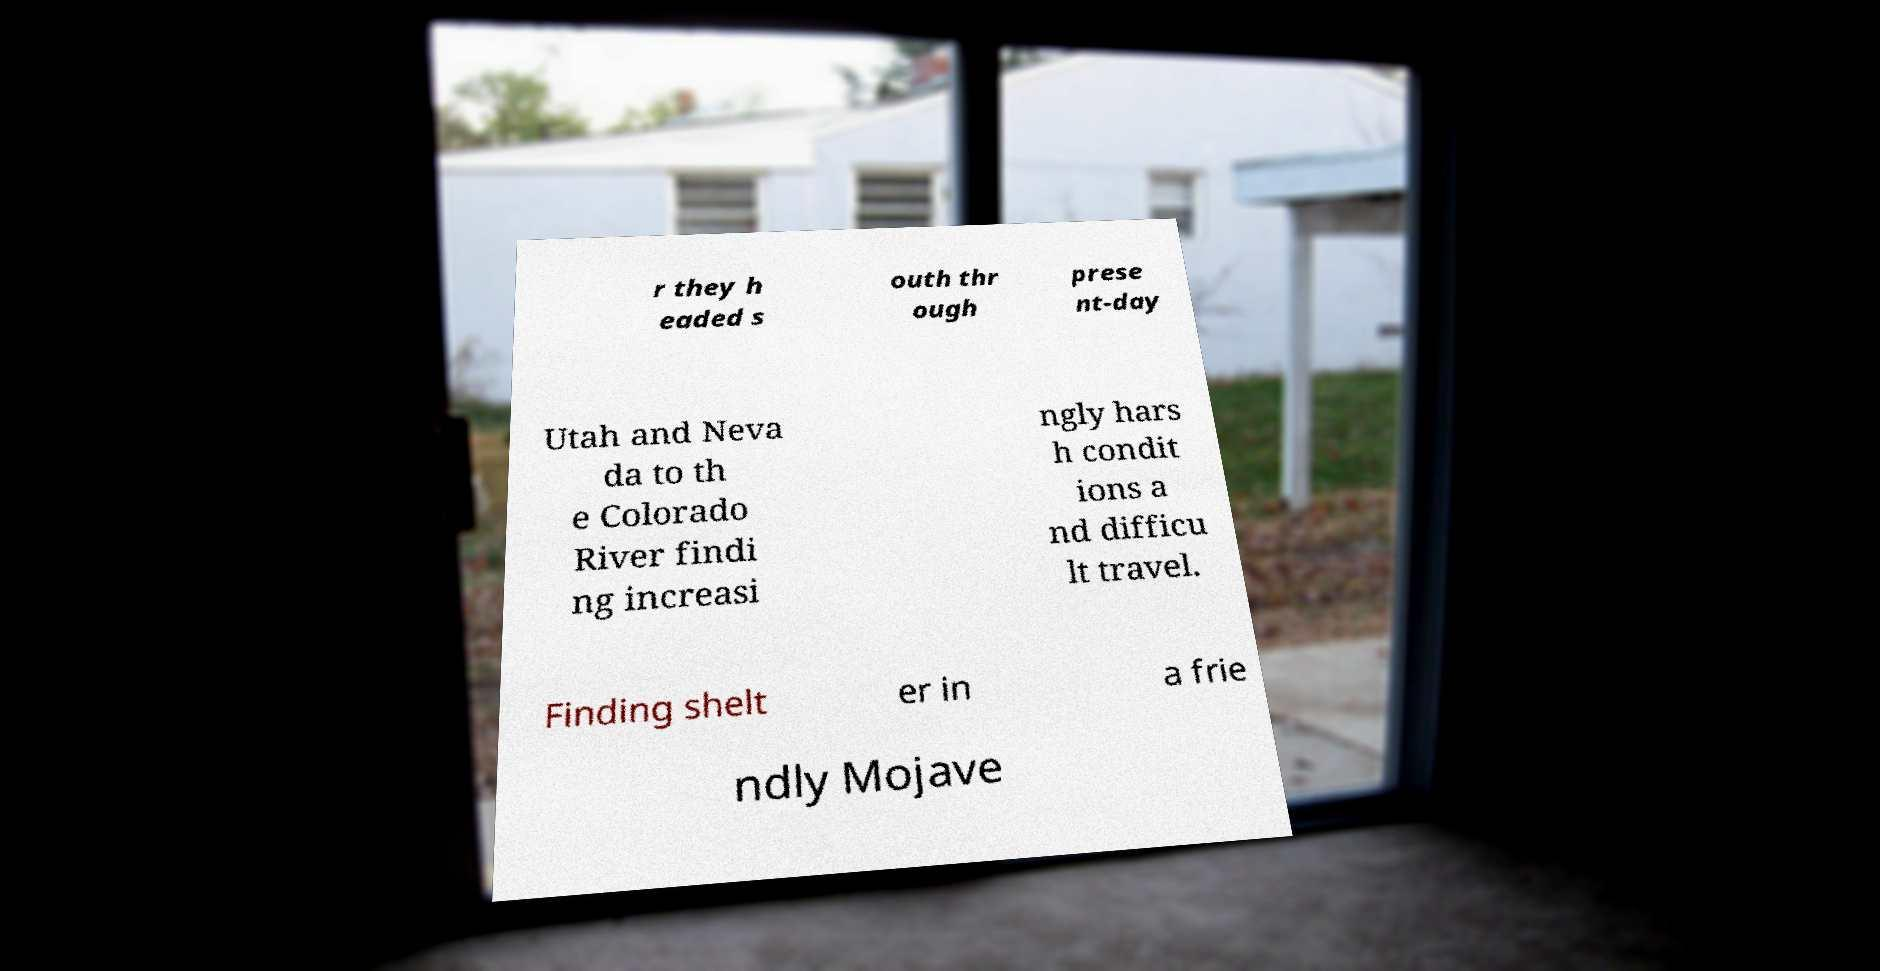Could you assist in decoding the text presented in this image and type it out clearly? r they h eaded s outh thr ough prese nt-day Utah and Neva da to th e Colorado River findi ng increasi ngly hars h condit ions a nd difficu lt travel. Finding shelt er in a frie ndly Mojave 